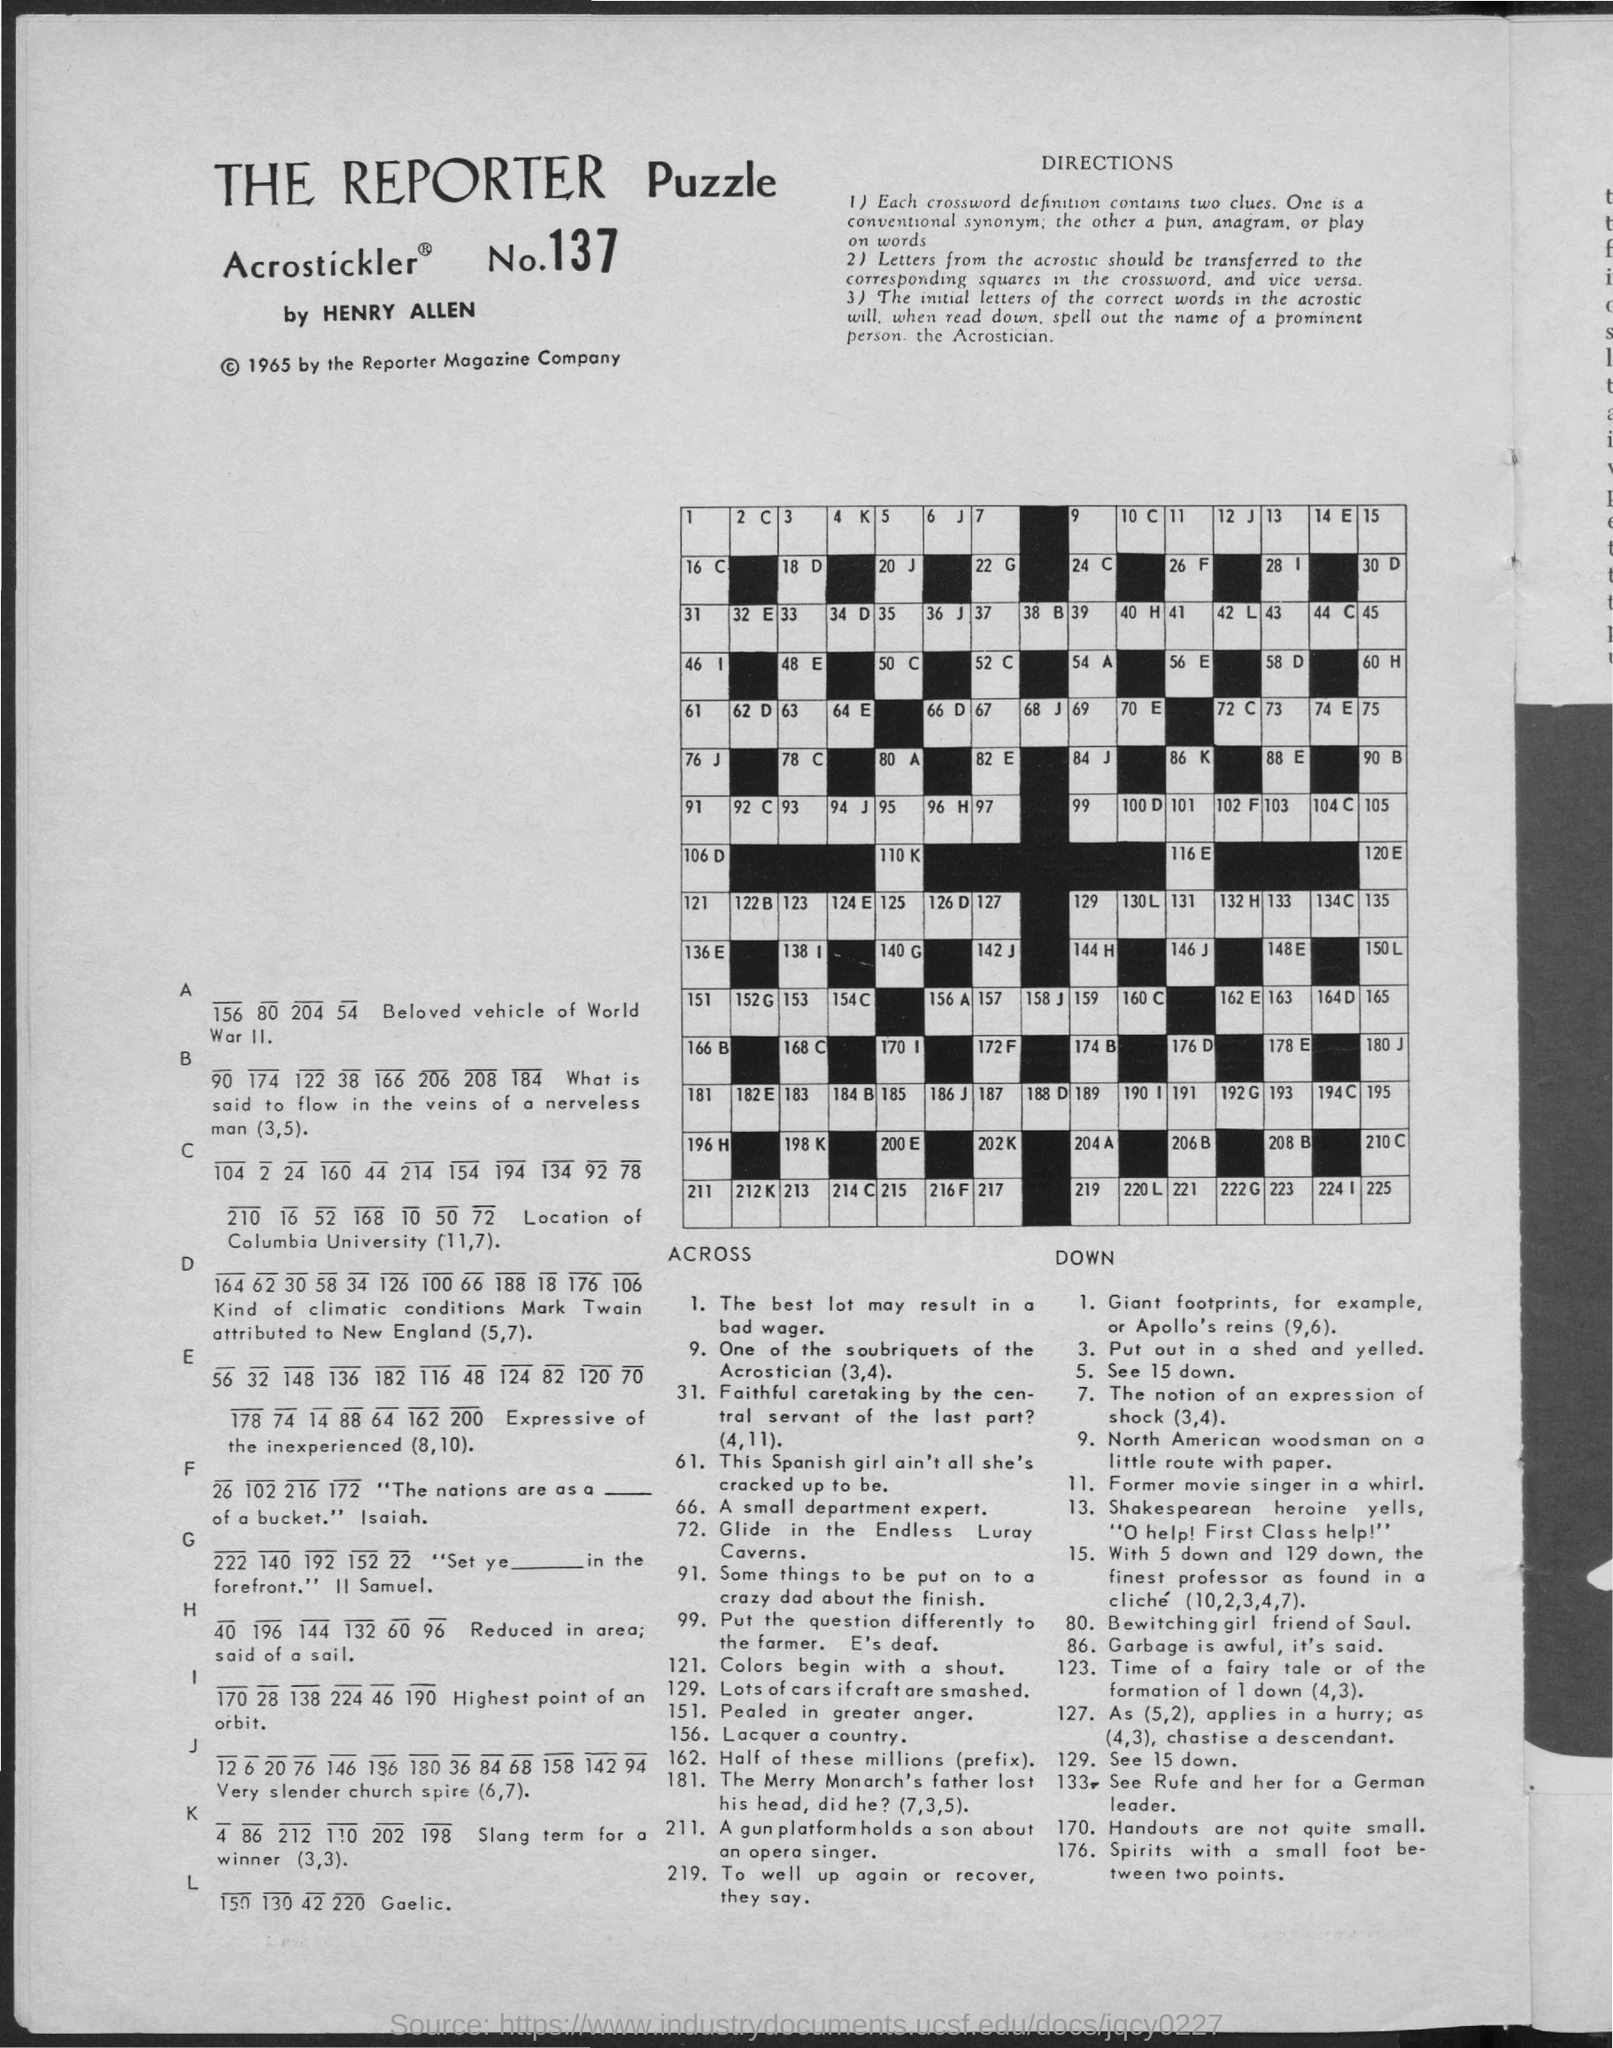What is the number of the reporter puzzle?
Offer a very short reply. 137. Who made this puzzle?
Provide a succinct answer. Henry Allen. Who holds copyright of the reporter puzzle?
Offer a terse response. REPORTER MAGAZINE COMPANY. In which year did the reporter magazine company registered this puzzle in?
Provide a succinct answer. 1965. 